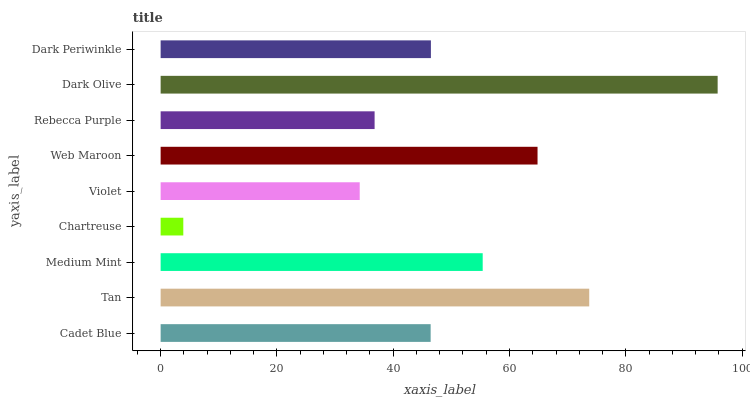Is Chartreuse the minimum?
Answer yes or no. Yes. Is Dark Olive the maximum?
Answer yes or no. Yes. Is Tan the minimum?
Answer yes or no. No. Is Tan the maximum?
Answer yes or no. No. Is Tan greater than Cadet Blue?
Answer yes or no. Yes. Is Cadet Blue less than Tan?
Answer yes or no. Yes. Is Cadet Blue greater than Tan?
Answer yes or no. No. Is Tan less than Cadet Blue?
Answer yes or no. No. Is Dark Periwinkle the high median?
Answer yes or no. Yes. Is Dark Periwinkle the low median?
Answer yes or no. Yes. Is Chartreuse the high median?
Answer yes or no. No. Is Medium Mint the low median?
Answer yes or no. No. 